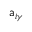<formula> <loc_0><loc_0><loc_500><loc_500>a _ { i \gamma }</formula> 